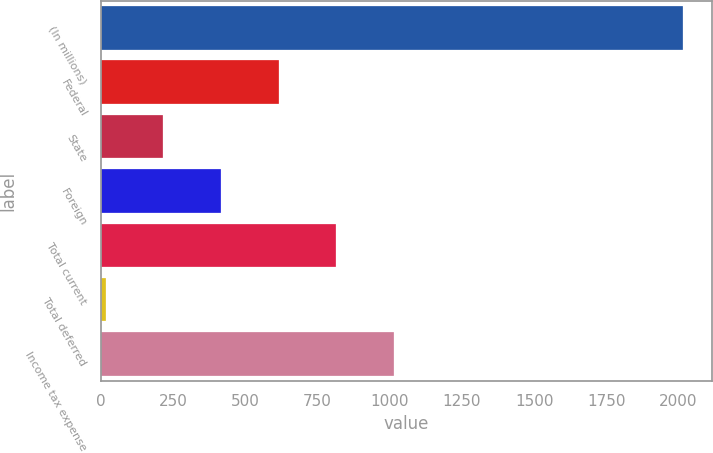<chart> <loc_0><loc_0><loc_500><loc_500><bar_chart><fcel>(In millions)<fcel>Federal<fcel>State<fcel>Foreign<fcel>Total current<fcel>Total deferred<fcel>Income tax expense<nl><fcel>2014<fcel>615.4<fcel>215.8<fcel>415.6<fcel>815.2<fcel>16<fcel>1015<nl></chart> 